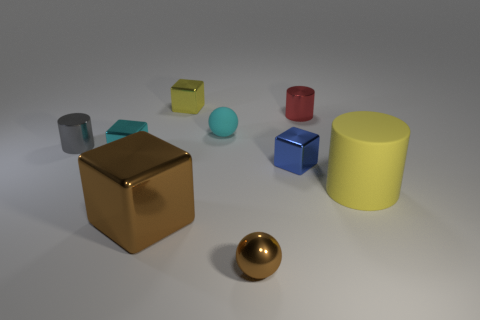There is a block in front of the yellow thing to the right of the small blue object; what is it made of?
Give a very brief answer. Metal. What number of yellow objects are either big cylinders or things?
Your response must be concise. 2. Are there any large cyan things?
Offer a very short reply. No. There is a block in front of the block right of the tiny yellow shiny block; is there a small cube in front of it?
Provide a short and direct response. No. Does the red shiny object have the same shape as the tiny cyan object behind the gray cylinder?
Your answer should be very brief. No. What color is the tiny metal block to the left of the small metal block behind the cyan metal block that is in front of the matte sphere?
Your response must be concise. Cyan. What number of objects are either shiny cylinders that are to the left of the small red metallic object or objects in front of the small cyan block?
Offer a terse response. 5. How many other objects are the same color as the tiny matte thing?
Give a very brief answer. 1. Is the shape of the yellow object that is to the left of the small red object the same as  the large brown thing?
Your answer should be very brief. Yes. Is the number of brown metallic balls on the right side of the tiny metal ball less than the number of tiny red shiny balls?
Your answer should be very brief. No. 